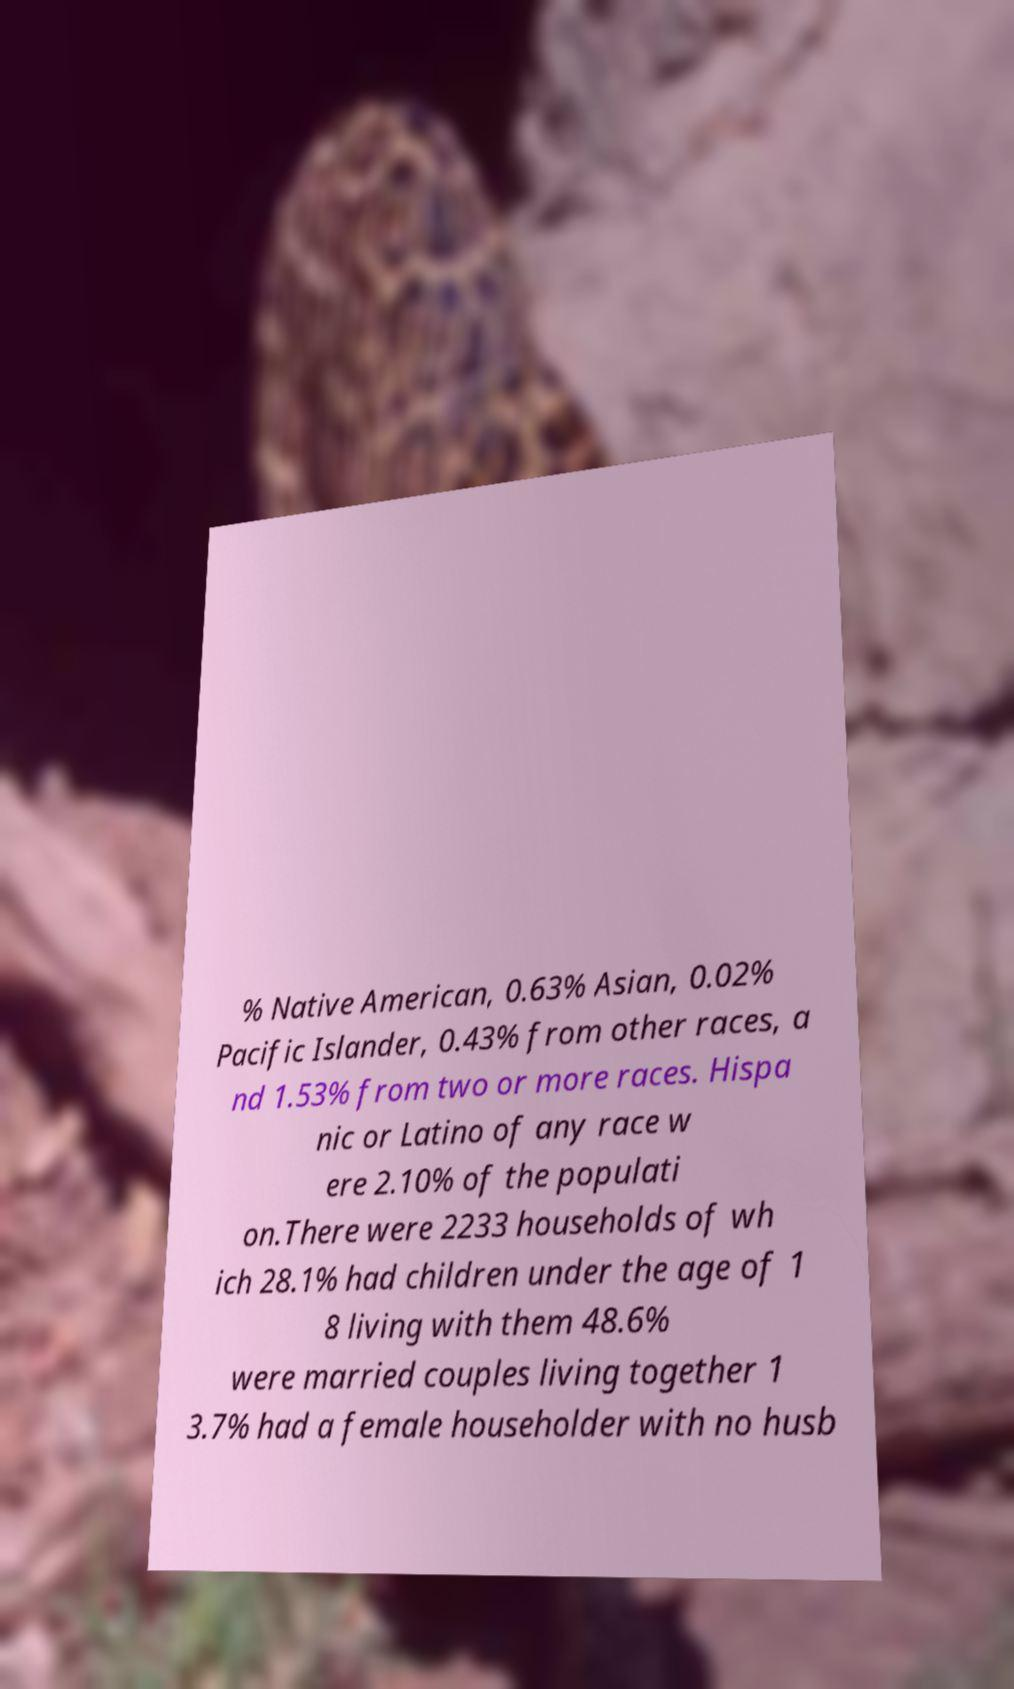I need the written content from this picture converted into text. Can you do that? % Native American, 0.63% Asian, 0.02% Pacific Islander, 0.43% from other races, a nd 1.53% from two or more races. Hispa nic or Latino of any race w ere 2.10% of the populati on.There were 2233 households of wh ich 28.1% had children under the age of 1 8 living with them 48.6% were married couples living together 1 3.7% had a female householder with no husb 